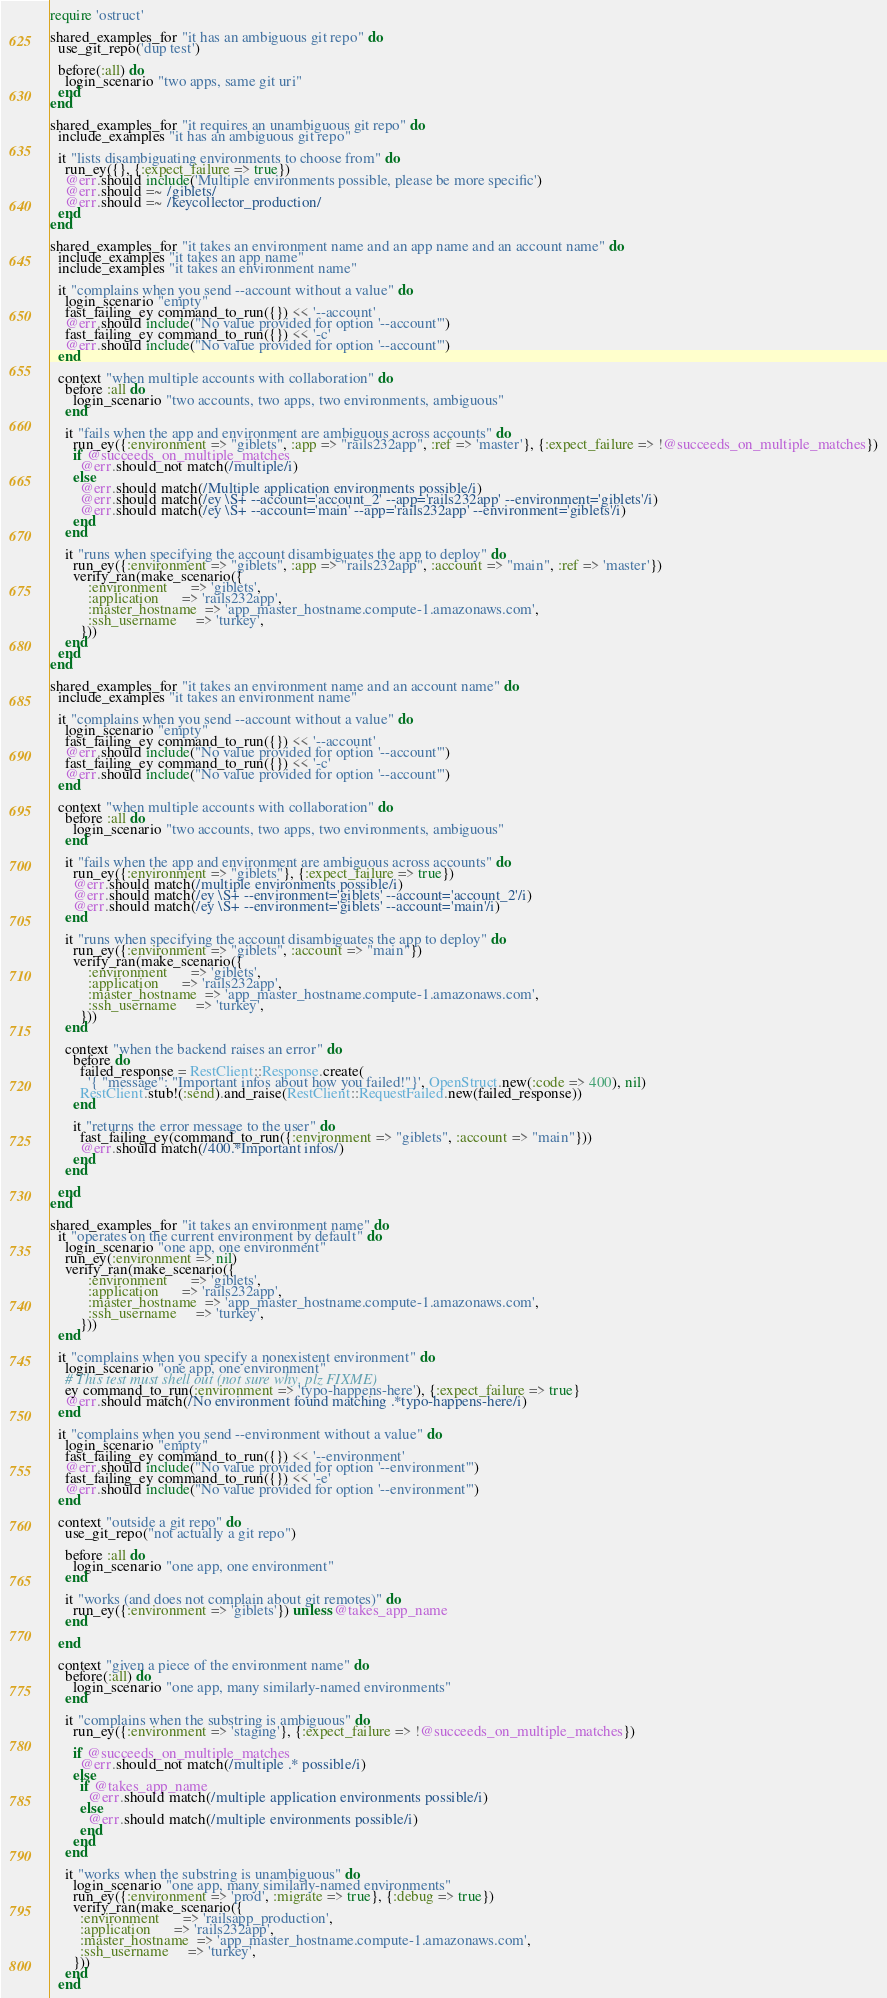Convert code to text. <code><loc_0><loc_0><loc_500><loc_500><_Ruby_>require 'ostruct'

shared_examples_for "it has an ambiguous git repo" do
  use_git_repo('dup test')

  before(:all) do
    login_scenario "two apps, same git uri"
  end
end

shared_examples_for "it requires an unambiguous git repo" do
  include_examples "it has an ambiguous git repo"

  it "lists disambiguating environments to choose from" do
    run_ey({}, {:expect_failure => true})
    @err.should include('Multiple environments possible, please be more specific')
    @err.should =~ /giblets/
    @err.should =~ /keycollector_production/
  end
end

shared_examples_for "it takes an environment name and an app name and an account name" do
  include_examples "it takes an app name"
  include_examples "it takes an environment name"

  it "complains when you send --account without a value" do
    login_scenario "empty"
    fast_failing_ey command_to_run({}) << '--account'
    @err.should include("No value provided for option '--account'")
    fast_failing_ey command_to_run({}) << '-c'
    @err.should include("No value provided for option '--account'")
  end

  context "when multiple accounts with collaboration" do
    before :all do
      login_scenario "two accounts, two apps, two environments, ambiguous"
    end

    it "fails when the app and environment are ambiguous across accounts" do
      run_ey({:environment => "giblets", :app => "rails232app", :ref => 'master'}, {:expect_failure => !@succeeds_on_multiple_matches})
      if @succeeds_on_multiple_matches
        @err.should_not match(/multiple/i)
      else
        @err.should match(/Multiple application environments possible/i)
        @err.should match(/ey \S+ --account='account_2' --app='rails232app' --environment='giblets'/i)
        @err.should match(/ey \S+ --account='main' --app='rails232app' --environment='giblets'/i)
      end
    end

    it "runs when specifying the account disambiguates the app to deploy" do
      run_ey({:environment => "giblets", :app => "rails232app", :account => "main", :ref => 'master'})
      verify_ran(make_scenario({
          :environment      => 'giblets',
          :application      => 'rails232app',
          :master_hostname  => 'app_master_hostname.compute-1.amazonaws.com',
          :ssh_username     => 'turkey',
        }))
    end
  end
end

shared_examples_for "it takes an environment name and an account name" do
  include_examples "it takes an environment name"

  it "complains when you send --account without a value" do
    login_scenario "empty"
    fast_failing_ey command_to_run({}) << '--account'
    @err.should include("No value provided for option '--account'")
    fast_failing_ey command_to_run({}) << '-c'
    @err.should include("No value provided for option '--account'")
  end

  context "when multiple accounts with collaboration" do
    before :all do
      login_scenario "two accounts, two apps, two environments, ambiguous"
    end

    it "fails when the app and environment are ambiguous across accounts" do
      run_ey({:environment => "giblets"}, {:expect_failure => true})
      @err.should match(/multiple environments possible/i)
      @err.should match(/ey \S+ --environment='giblets' --account='account_2'/i)
      @err.should match(/ey \S+ --environment='giblets' --account='main'/i)
    end

    it "runs when specifying the account disambiguates the app to deploy" do
      run_ey({:environment => "giblets", :account => "main"})
      verify_ran(make_scenario({
          :environment      => 'giblets',
          :application      => 'rails232app',
          :master_hostname  => 'app_master_hostname.compute-1.amazonaws.com',
          :ssh_username     => 'turkey',
        }))
    end

    context "when the backend raises an error" do
      before do
        failed_response = RestClient::Response.create(
          '{ "message": "Important infos about how you failed!"}', OpenStruct.new(:code => 400), nil)
        RestClient.stub!(:send).and_raise(RestClient::RequestFailed.new(failed_response))
      end

      it "returns the error message to the user" do
        fast_failing_ey(command_to_run({:environment => "giblets", :account => "main"}))
        @err.should match(/400.*Important infos/)
      end
    end

  end
end

shared_examples_for "it takes an environment name" do
  it "operates on the current environment by default" do
    login_scenario "one app, one environment"
    run_ey(:environment => nil)
    verify_ran(make_scenario({
          :environment      => 'giblets',
          :application      => 'rails232app',
          :master_hostname  => 'app_master_hostname.compute-1.amazonaws.com',
          :ssh_username     => 'turkey',
        }))
  end

  it "complains when you specify a nonexistent environment" do
    login_scenario "one app, one environment"
    # This test must shell out (not sure why, plz FIXME)
    ey command_to_run(:environment => 'typo-happens-here'), {:expect_failure => true}
    @err.should match(/No environment found matching .*typo-happens-here/i)
  end

  it "complains when you send --environment without a value" do
    login_scenario "empty"
    fast_failing_ey command_to_run({}) << '--environment'
    @err.should include("No value provided for option '--environment'")
    fast_failing_ey command_to_run({}) << '-e'
    @err.should include("No value provided for option '--environment'")
  end

  context "outside a git repo" do
    use_git_repo("not actually a git repo")

    before :all do
      login_scenario "one app, one environment"
    end

    it "works (and does not complain about git remotes)" do
      run_ey({:environment => 'giblets'}) unless @takes_app_name
    end

  end

  context "given a piece of the environment name" do
    before(:all) do
      login_scenario "one app, many similarly-named environments"
    end

    it "complains when the substring is ambiguous" do
      run_ey({:environment => 'staging'}, {:expect_failure => !@succeeds_on_multiple_matches})

      if @succeeds_on_multiple_matches
        @err.should_not match(/multiple .* possible/i)
      else
        if @takes_app_name
          @err.should match(/multiple application environments possible/i)
        else
          @err.should match(/multiple environments possible/i)
        end
      end
    end

    it "works when the substring is unambiguous" do
      login_scenario "one app, many similarly-named environments"
      run_ey({:environment => 'prod', :migrate => true}, {:debug => true})
      verify_ran(make_scenario({
        :environment      => 'railsapp_production',
        :application      => 'rails232app',
        :master_hostname  => 'app_master_hostname.compute-1.amazonaws.com',
        :ssh_username     => 'turkey',
      }))
    end
  end
</code> 